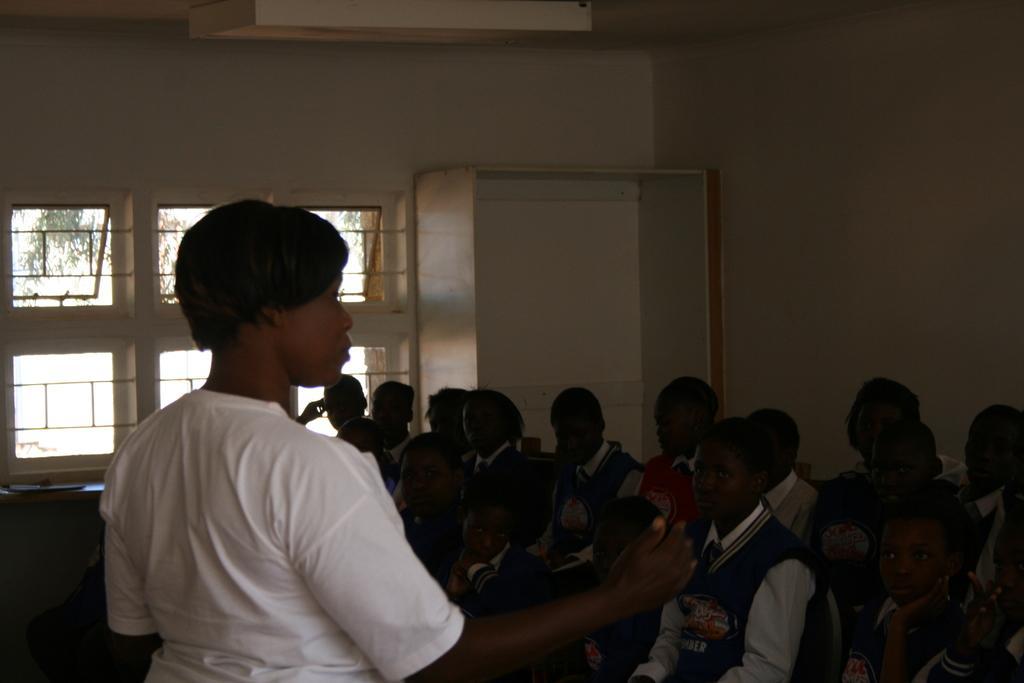Please provide a concise description of this image. Here we can see few children and a woman. In the background there is a wall, window, and a rack. 